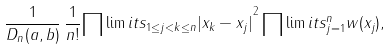Convert formula to latex. <formula><loc_0><loc_0><loc_500><loc_500>\frac { 1 } { D _ { n } ( a , b ) } \, \frac { 1 } { n ! } { \prod \lim i t s _ { 1 \leq j < k \leq n } | x _ { k } - x _ { j } | } ^ { 2 } \prod \lim i t s ^ { n } _ { j = 1 } w ( x _ { j } ) ,</formula> 